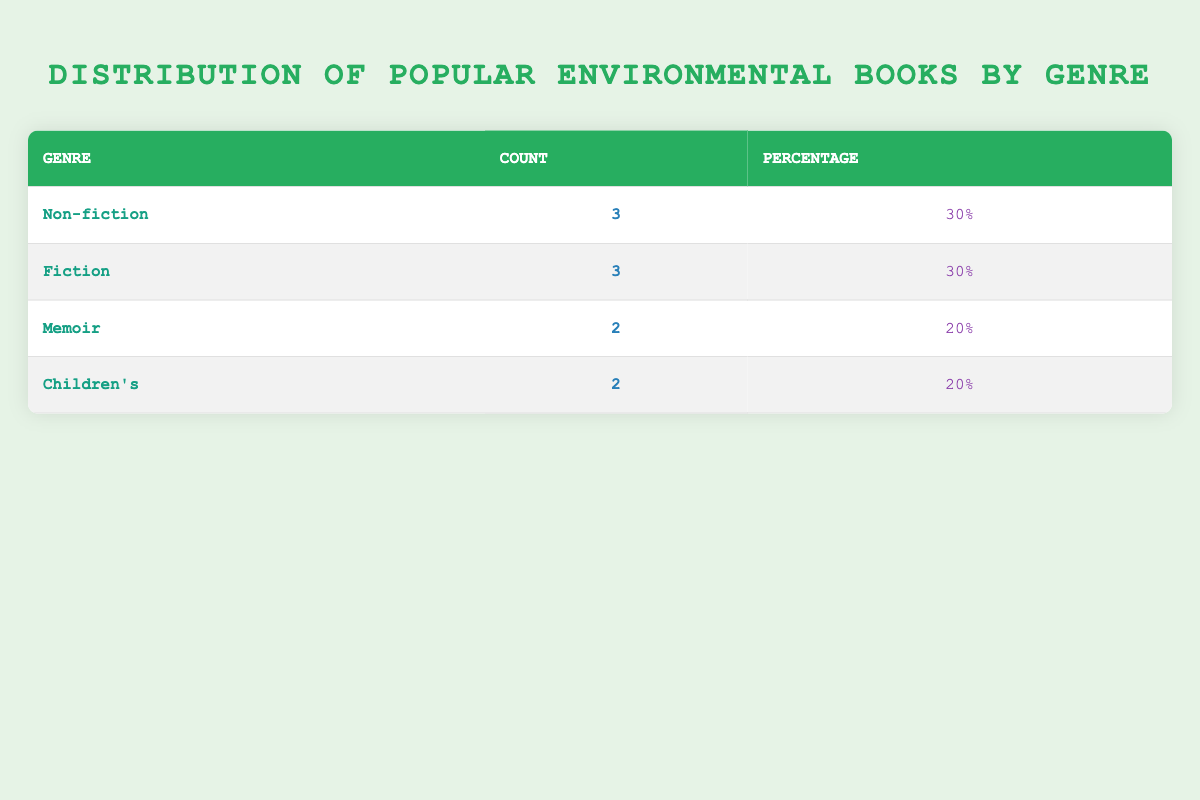What is the total number of books listed in the table? There are a total of 10 books in the table, summing the counts from each genre category: 3 Non-fiction + 3 Fiction + 2 Memoir + 2 Children's = 10
Answer: 10 What percentage of the books are classified as Non-fiction? There are 3 Non-fiction books out of a total of 10 books. To find the percentage, the formula is (3/10) * 100 = 30%.
Answer: 30% Is there any book listed in the Memoir genre that has sold more than 1,000,000 copies? The table shows that the highest copies sold in the Memoir genre is 1,000,000 (for "The Last Child in the Woods"), so no book has sold more than this amount in this genre.
Answer: No Which genre has the highest number of books listed? Non-fiction and Fiction both have 3 books each, while Memoir and Children's each have 2. Therefore, Non-fiction and Fiction tie for the highest number of books.
Answer: Non-fiction and Fiction What is the combined total of copies sold for the Fiction genre books? The copies sold for each Fiction book are: The Overstory (600,000) + The Lorax (2,500,000) + Flight Behavior (500,000). Summing these gives: 600,000 + 2,500,000 + 500,000 = 3,600,000.
Answer: 3,600,000 If we wanted to find the average number of copies sold per book in the Children's genre, what would that be? There are 2 books in the Children's genre with copies sold: 300,000 and 750,000. To find the average, we sum these: 300,000 + 750,000 = 1,050,000. Then divide by the number of books: 1,050,000 / 2 = 525,000.
Answer: 525,000 How many genres have exactly 2 books listed? The Memoir genre has 2 books and the Children's genre also has 2 books. Therefore, there are 2 genres that have exactly 2 books.
Answer: 2 Is "Silent Spring" the only book in the Non-fiction genre that has sold over 1,000,000 copies? Yes, "Silent Spring" is the only Non-fiction book listed with 5,000,000 copies sold, while the other two Non-fiction books have sold less than 1,000,000 copies.
Answer: Yes 